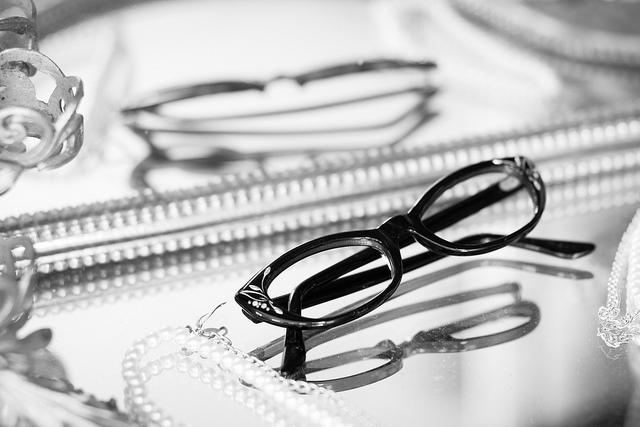What object is black on the vanity?
Keep it brief. Glasses. Are the glasses plastic?
Short answer required. Yes. Is this a color or black and white photo?
Keep it brief. Black and white. 